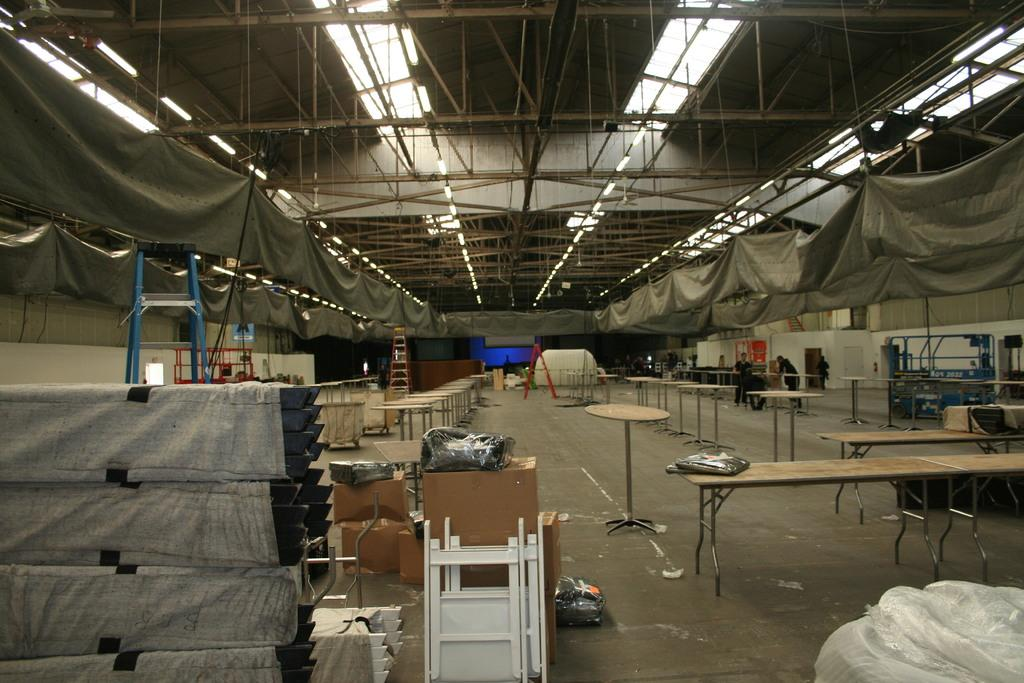What type of furniture is present in the image? There are tables in the image. What equipment can be seen in the image? There are ladders and rods in the image. What items are used for storage in the image? There are boxes in the image. What is used for illumination in the image? There are lights in the image. What can be seen on the floor in the image? There are people standing on the floor in the image. What degree is the person teaching in the image? There is no person teaching in the image, nor is there any indication of a degree. What type of cream is being used by the people in the image? There is no cream present in the image. 